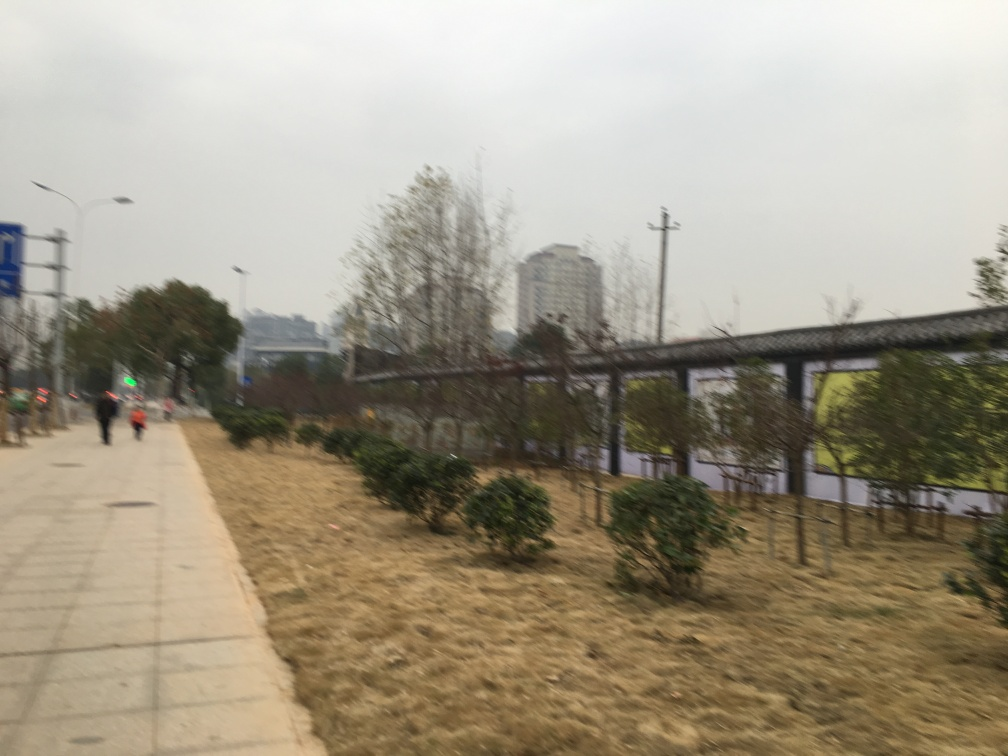Has the image lost a lot of texture details of the green plants? Indeed, the image appears to have lost some texture details of the green plants, likely as a result of motion blur or a low-quality camera setting, which affects the clarity and crispness of the vegetation in the photo. 